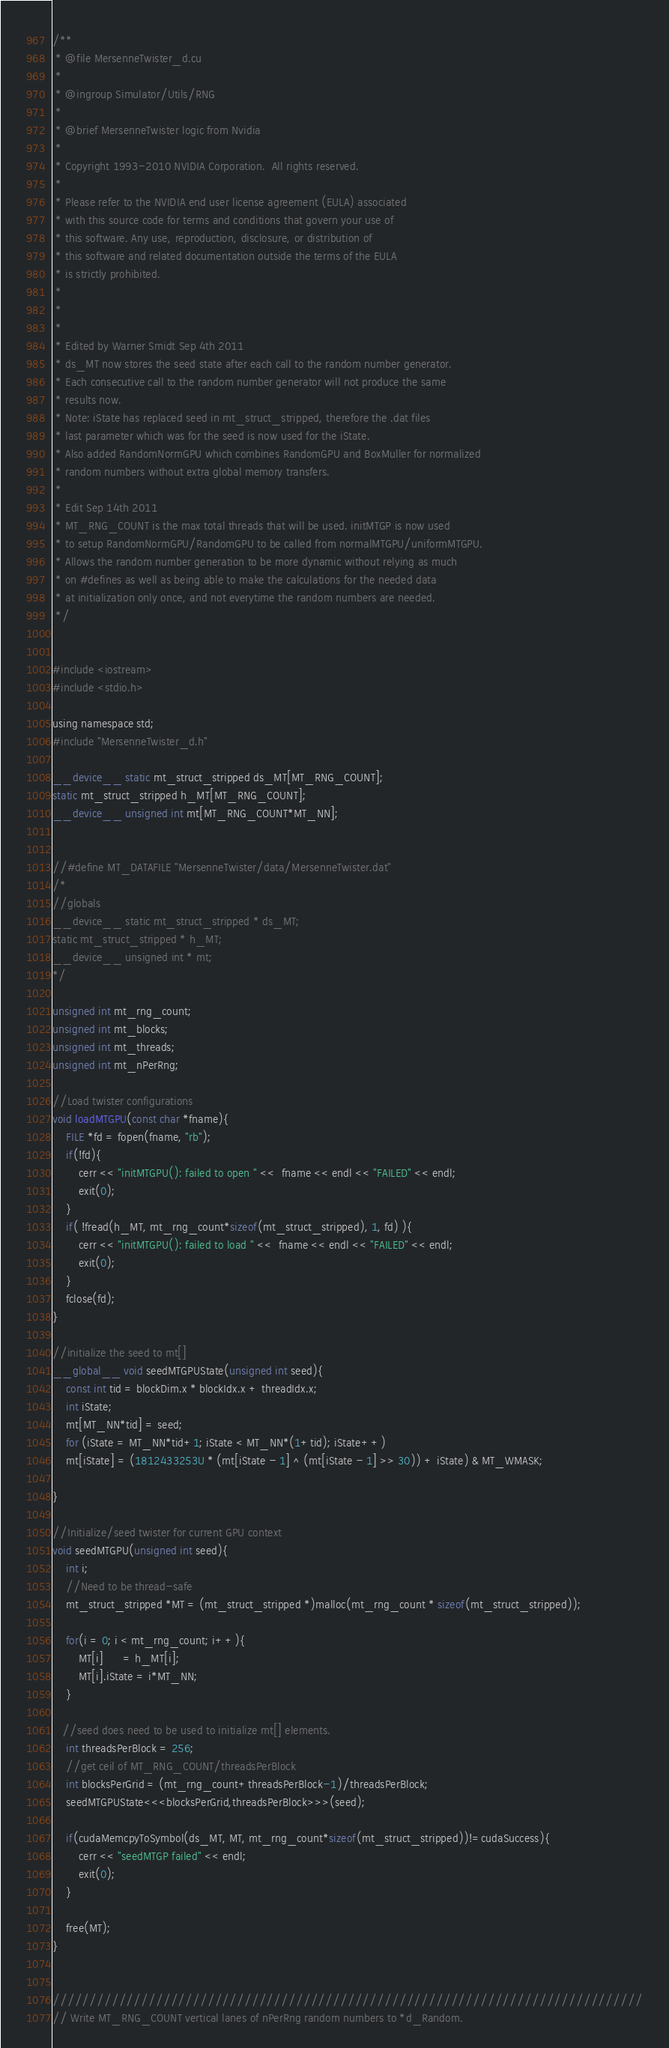Convert code to text. <code><loc_0><loc_0><loc_500><loc_500><_Cuda_>/**
 * @file MersenneTwister_d.cu
 * 
 * @ingroup Simulator/Utils/RNG
 * 
 * @brief MersenneTwister logic from Nvidia
 * 
 * Copyright 1993-2010 NVIDIA Corporation.  All rights reserved.
 *
 * Please refer to the NVIDIA end user license agreement (EULA) associated
 * with this source code for terms and conditions that govern your use of
 * this software. Any use, reproduction, disclosure, or distribution of
 * this software and related documentation outside the terms of the EULA
 * is strictly prohibited.
 *
 *
 *
 * Edited by Warner Smidt Sep 4th 2011
 * ds_MT now stores the seed state after each call to the random number generator. 
 * Each consecutive call to the random number generator will not produce the same 
 * results now. 
 * Note: iState has replaced seed in mt_struct_stripped, therefore the .dat files
 * last parameter which was for the seed is now used for the iState.
 * Also added RandomNormGPU which combines RandomGPU and BoxMuller for normalized
 * random numbers without extra global memory transfers. 
 *
 * Edit Sep 14th 2011
 * MT_RNG_COUNT is the max total threads that will be used. initMTGP is now used 
 * to setup RandomNormGPU/RandomGPU to be called from normalMTGPU/uniformMTGPU. 
 * Allows the random number generation to be more dynamic without relying as much 
 * on #defines as well as being able to make the calculations for the needed data  
 * at initialization only once, and not everytime the random numbers are needed. 
 */


#include <iostream>
#include <stdio.h>

using namespace std;
#include "MersenneTwister_d.h"

__device__ static mt_struct_stripped ds_MT[MT_RNG_COUNT];
static mt_struct_stripped h_MT[MT_RNG_COUNT];
__device__ unsigned int mt[MT_RNG_COUNT*MT_NN];


//#define MT_DATAFILE "MersenneTwister/data/MersenneTwister.dat"
/*
//globals
__device__ static mt_struct_stripped * ds_MT;
static mt_struct_stripped * h_MT;
__device__ unsigned int * mt;
*/

unsigned int mt_rng_count;
unsigned int mt_blocks;
unsigned int mt_threads;
unsigned int mt_nPerRng;

//Load twister configurations
void loadMTGPU(const char *fname){
	FILE *fd = fopen(fname, "rb");
	if(!fd){
		cerr << "initMTGPU(): failed to open " <<  fname << endl << "FAILED" << endl;
		exit(0);
	}
	if( !fread(h_MT, mt_rng_count*sizeof(mt_struct_stripped), 1, fd) ){
		cerr << "initMTGPU(): failed to load " <<  fname << endl << "FAILED" << endl;
		exit(0);
	}
	fclose(fd);
}

//initialize the seed to mt[]
__global__ void seedMTGPUState(unsigned int seed){
	const int tid = blockDim.x * blockIdx.x + threadIdx.x;
	int iState;
	mt[MT_NN*tid] = seed;
	for (iState = MT_NN*tid+1; iState < MT_NN*(1+tid); iState++)
	mt[iState] = (1812433253U * (mt[iState - 1] ^ (mt[iState - 1] >> 30)) + iState) & MT_WMASK;

}

//Initialize/seed twister for current GPU context
void seedMTGPU(unsigned int seed){
	int i;
    //Need to be thread-safe
	mt_struct_stripped *MT = (mt_struct_stripped *)malloc(mt_rng_count * sizeof(mt_struct_stripped));

	for(i = 0; i < mt_rng_count; i++){
		MT[i]      = h_MT[i];
		MT[i].iState = i*MT_NN;
    }

   //seed does need to be used to initialize mt[] elements.
	int threadsPerBlock = 256;
	//get ceil of MT_RNG_COUNT/threadsPerBlock
	int blocksPerGrid = (mt_rng_count+threadsPerBlock-1)/threadsPerBlock; 
	seedMTGPUState<<<blocksPerGrid,threadsPerBlock>>>(seed);

	if(cudaMemcpyToSymbol(ds_MT, MT, mt_rng_count*sizeof(mt_struct_stripped))!=cudaSuccess){
		cerr << "seedMTGP failed" << endl;
		exit(0);
	}

	free(MT);
}


////////////////////////////////////////////////////////////////////////////////
// Write MT_RNG_COUNT vertical lanes of nPerRng random numbers to *d_Random.</code> 